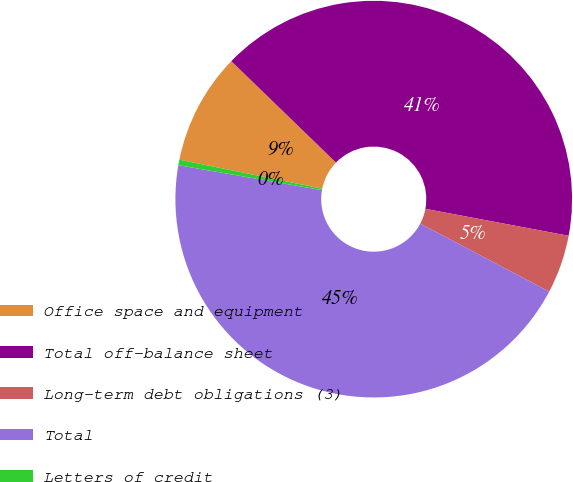Convert chart to OTSL. <chart><loc_0><loc_0><loc_500><loc_500><pie_chart><fcel>Office space and equipment<fcel>Total off-balance sheet<fcel>Long-term debt obligations (3)<fcel>Total<fcel>Letters of credit<nl><fcel>9.06%<fcel>40.71%<fcel>4.76%<fcel>45.02%<fcel>0.45%<nl></chart> 